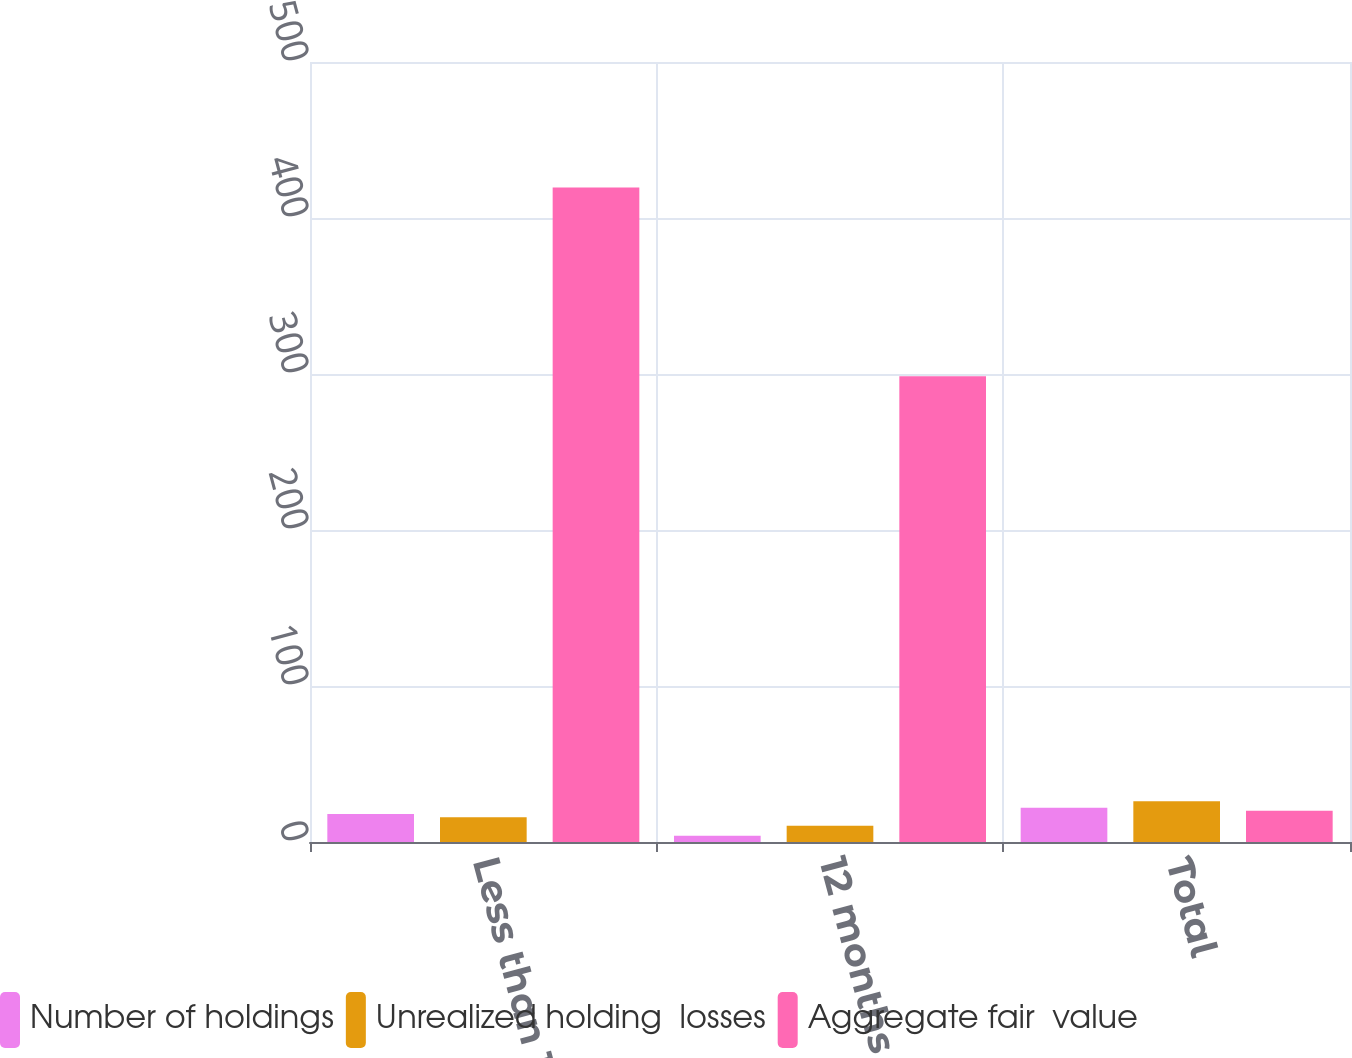<chart> <loc_0><loc_0><loc_500><loc_500><stacked_bar_chart><ecel><fcel>Less than 12 months<fcel>12 months or more<fcel>Total<nl><fcel>Number of holdings<fcel>18<fcel>4<fcel>22<nl><fcel>Unrealized holding  losses<fcel>15.8<fcel>10.4<fcel>26.2<nl><fcel>Aggregate fair  value<fcel>419.6<fcel>298.6<fcel>20<nl></chart> 